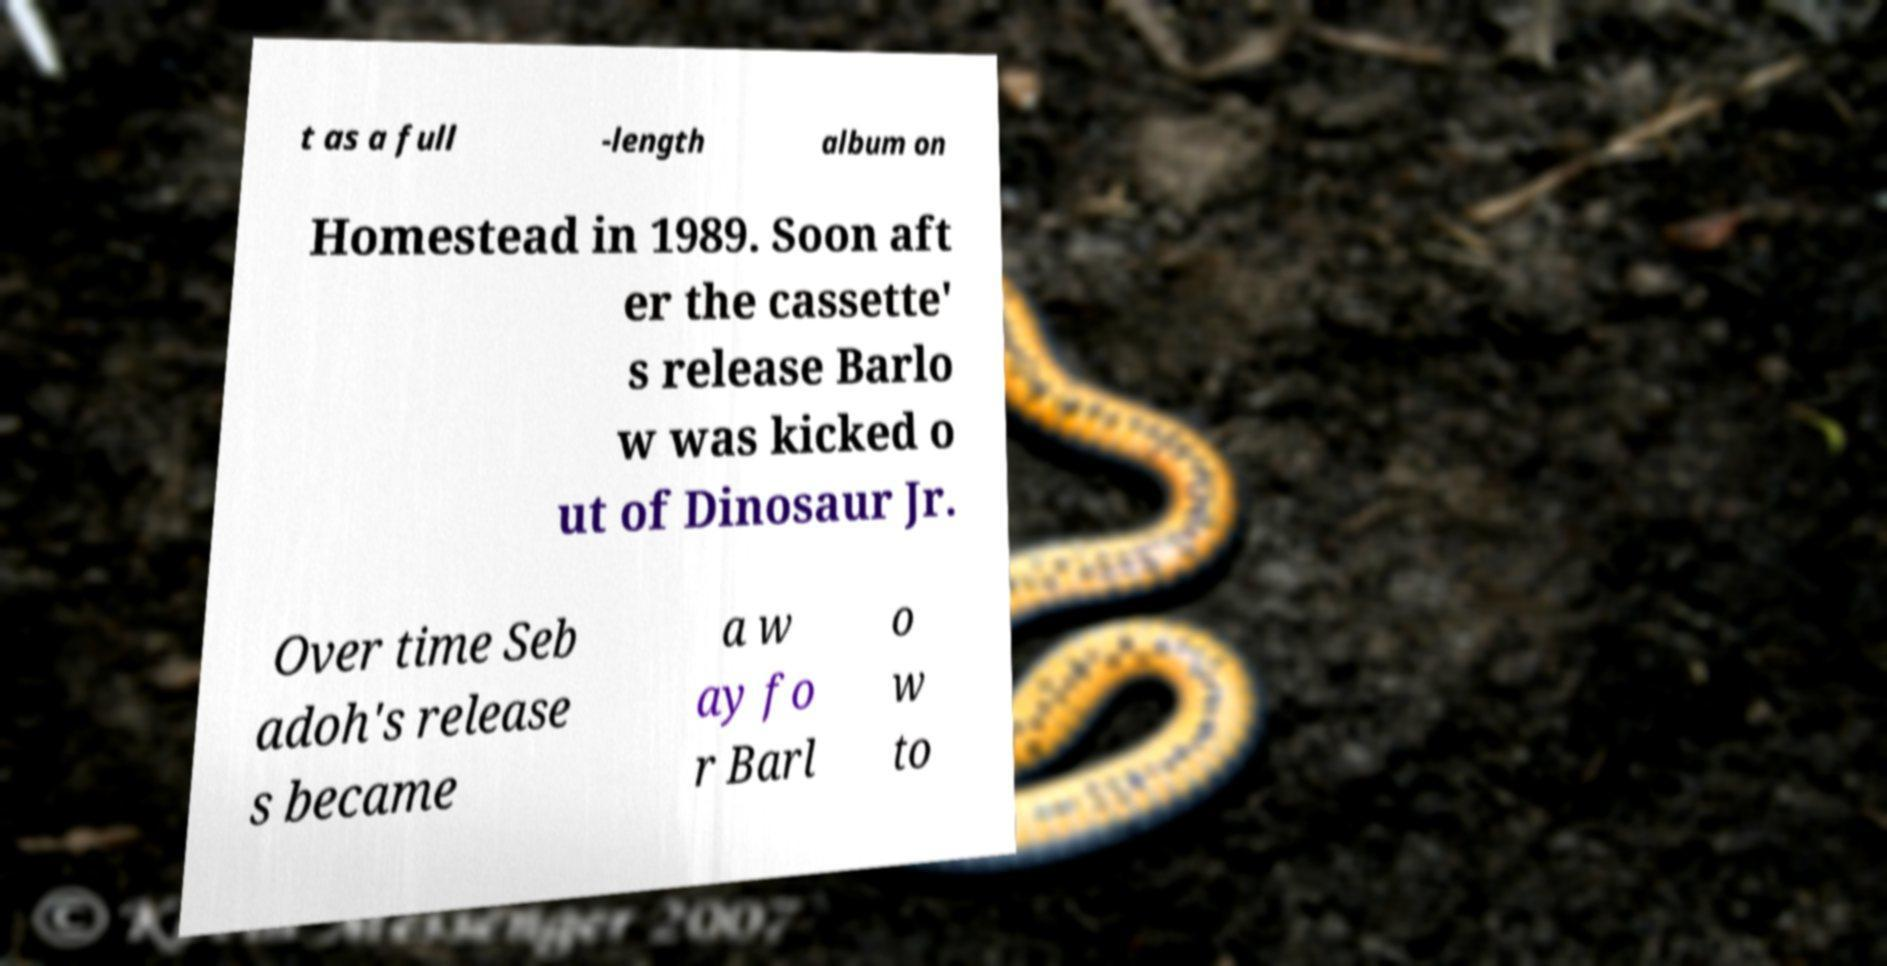For documentation purposes, I need the text within this image transcribed. Could you provide that? t as a full -length album on Homestead in 1989. Soon aft er the cassette' s release Barlo w was kicked o ut of Dinosaur Jr. Over time Seb adoh's release s became a w ay fo r Barl o w to 